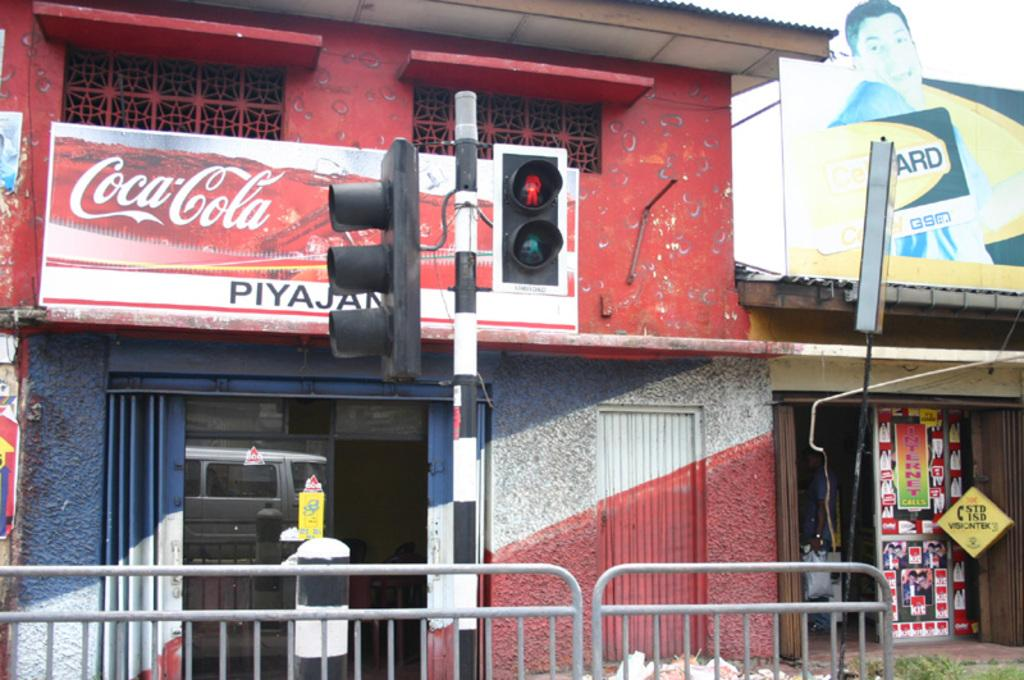What is located at the bottom of the image? There is a grill at the bottom of the image. What can be seen in the middle of the image? There are traffic lights in the middle of the image. What type of establishments can be seen in the background of the image? There are shops visible in the background of the image. What is on the right side of the image? There is a hoarding on the right side of the image. Can you tell me how many buttons are on the traffic lights in the image? There is no mention of buttons on the traffic lights in the image; they are simply depicted as lights. What is the afterthought in the image? There is no afterthought mentioned or depicted in the image. 